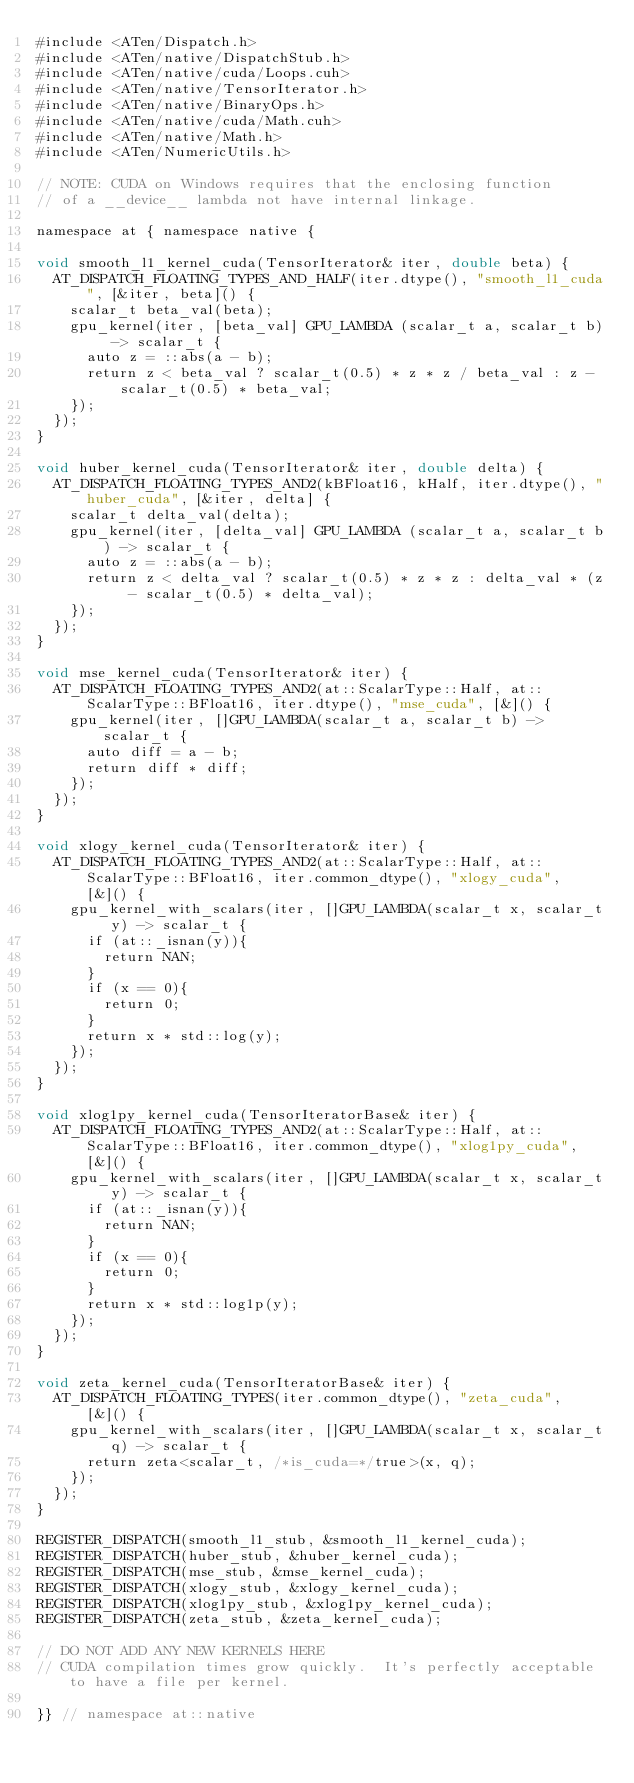<code> <loc_0><loc_0><loc_500><loc_500><_Cuda_>#include <ATen/Dispatch.h>
#include <ATen/native/DispatchStub.h>
#include <ATen/native/cuda/Loops.cuh>
#include <ATen/native/TensorIterator.h>
#include <ATen/native/BinaryOps.h>
#include <ATen/native/cuda/Math.cuh>
#include <ATen/native/Math.h>
#include <ATen/NumericUtils.h>

// NOTE: CUDA on Windows requires that the enclosing function
// of a __device__ lambda not have internal linkage.

namespace at { namespace native {

void smooth_l1_kernel_cuda(TensorIterator& iter, double beta) {
  AT_DISPATCH_FLOATING_TYPES_AND_HALF(iter.dtype(), "smooth_l1_cuda", [&iter, beta]() {
    scalar_t beta_val(beta);
    gpu_kernel(iter, [beta_val] GPU_LAMBDA (scalar_t a, scalar_t b) -> scalar_t {
      auto z = ::abs(a - b);
      return z < beta_val ? scalar_t(0.5) * z * z / beta_val : z - scalar_t(0.5) * beta_val;
    });
  });
}

void huber_kernel_cuda(TensorIterator& iter, double delta) {
  AT_DISPATCH_FLOATING_TYPES_AND2(kBFloat16, kHalf, iter.dtype(), "huber_cuda", [&iter, delta] {
    scalar_t delta_val(delta);
    gpu_kernel(iter, [delta_val] GPU_LAMBDA (scalar_t a, scalar_t b) -> scalar_t {
      auto z = ::abs(a - b);
      return z < delta_val ? scalar_t(0.5) * z * z : delta_val * (z - scalar_t(0.5) * delta_val);
    });
  });
}

void mse_kernel_cuda(TensorIterator& iter) {
  AT_DISPATCH_FLOATING_TYPES_AND2(at::ScalarType::Half, at::ScalarType::BFloat16, iter.dtype(), "mse_cuda", [&]() {
    gpu_kernel(iter, []GPU_LAMBDA(scalar_t a, scalar_t b) -> scalar_t {
      auto diff = a - b;
      return diff * diff;
    });
  });
}

void xlogy_kernel_cuda(TensorIterator& iter) {
  AT_DISPATCH_FLOATING_TYPES_AND2(at::ScalarType::Half, at::ScalarType::BFloat16, iter.common_dtype(), "xlogy_cuda", [&]() {
    gpu_kernel_with_scalars(iter, []GPU_LAMBDA(scalar_t x, scalar_t y) -> scalar_t {
      if (at::_isnan(y)){
        return NAN;
      }
      if (x == 0){
        return 0;
      }
      return x * std::log(y);
    });
  });
}

void xlog1py_kernel_cuda(TensorIteratorBase& iter) {
  AT_DISPATCH_FLOATING_TYPES_AND2(at::ScalarType::Half, at::ScalarType::BFloat16, iter.common_dtype(), "xlog1py_cuda", [&]() {
    gpu_kernel_with_scalars(iter, []GPU_LAMBDA(scalar_t x, scalar_t y) -> scalar_t {
      if (at::_isnan(y)){
        return NAN;
      }
      if (x == 0){
        return 0;
      }
      return x * std::log1p(y);
    });
  });
}

void zeta_kernel_cuda(TensorIteratorBase& iter) {
  AT_DISPATCH_FLOATING_TYPES(iter.common_dtype(), "zeta_cuda", [&]() {
    gpu_kernel_with_scalars(iter, []GPU_LAMBDA(scalar_t x, scalar_t q) -> scalar_t {
      return zeta<scalar_t, /*is_cuda=*/true>(x, q);
    });
  });
}

REGISTER_DISPATCH(smooth_l1_stub, &smooth_l1_kernel_cuda);
REGISTER_DISPATCH(huber_stub, &huber_kernel_cuda);
REGISTER_DISPATCH(mse_stub, &mse_kernel_cuda);
REGISTER_DISPATCH(xlogy_stub, &xlogy_kernel_cuda);
REGISTER_DISPATCH(xlog1py_stub, &xlog1py_kernel_cuda);
REGISTER_DISPATCH(zeta_stub, &zeta_kernel_cuda);

// DO NOT ADD ANY NEW KERNELS HERE
// CUDA compilation times grow quickly.  It's perfectly acceptable to have a file per kernel.

}} // namespace at::native
</code> 